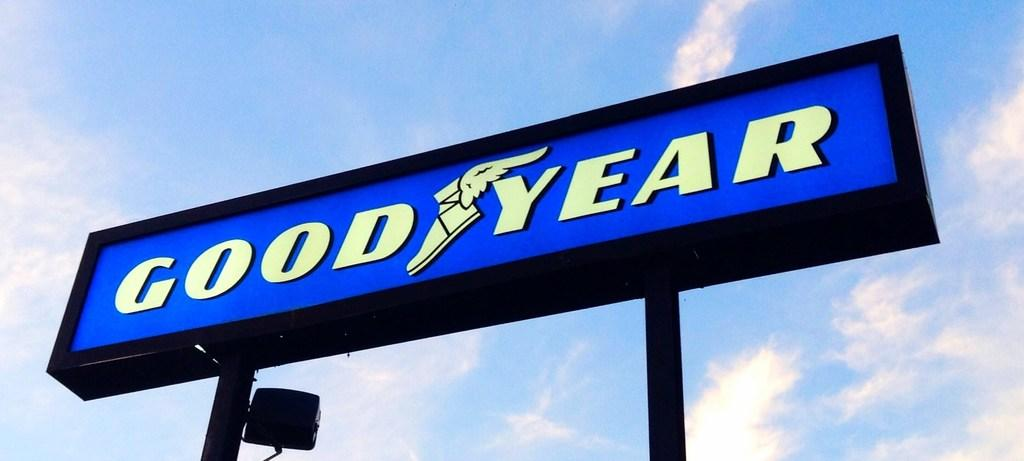<image>
Offer a succinct explanation of the picture presented. A blue Good Year sign stands below a cloudy blue sky 